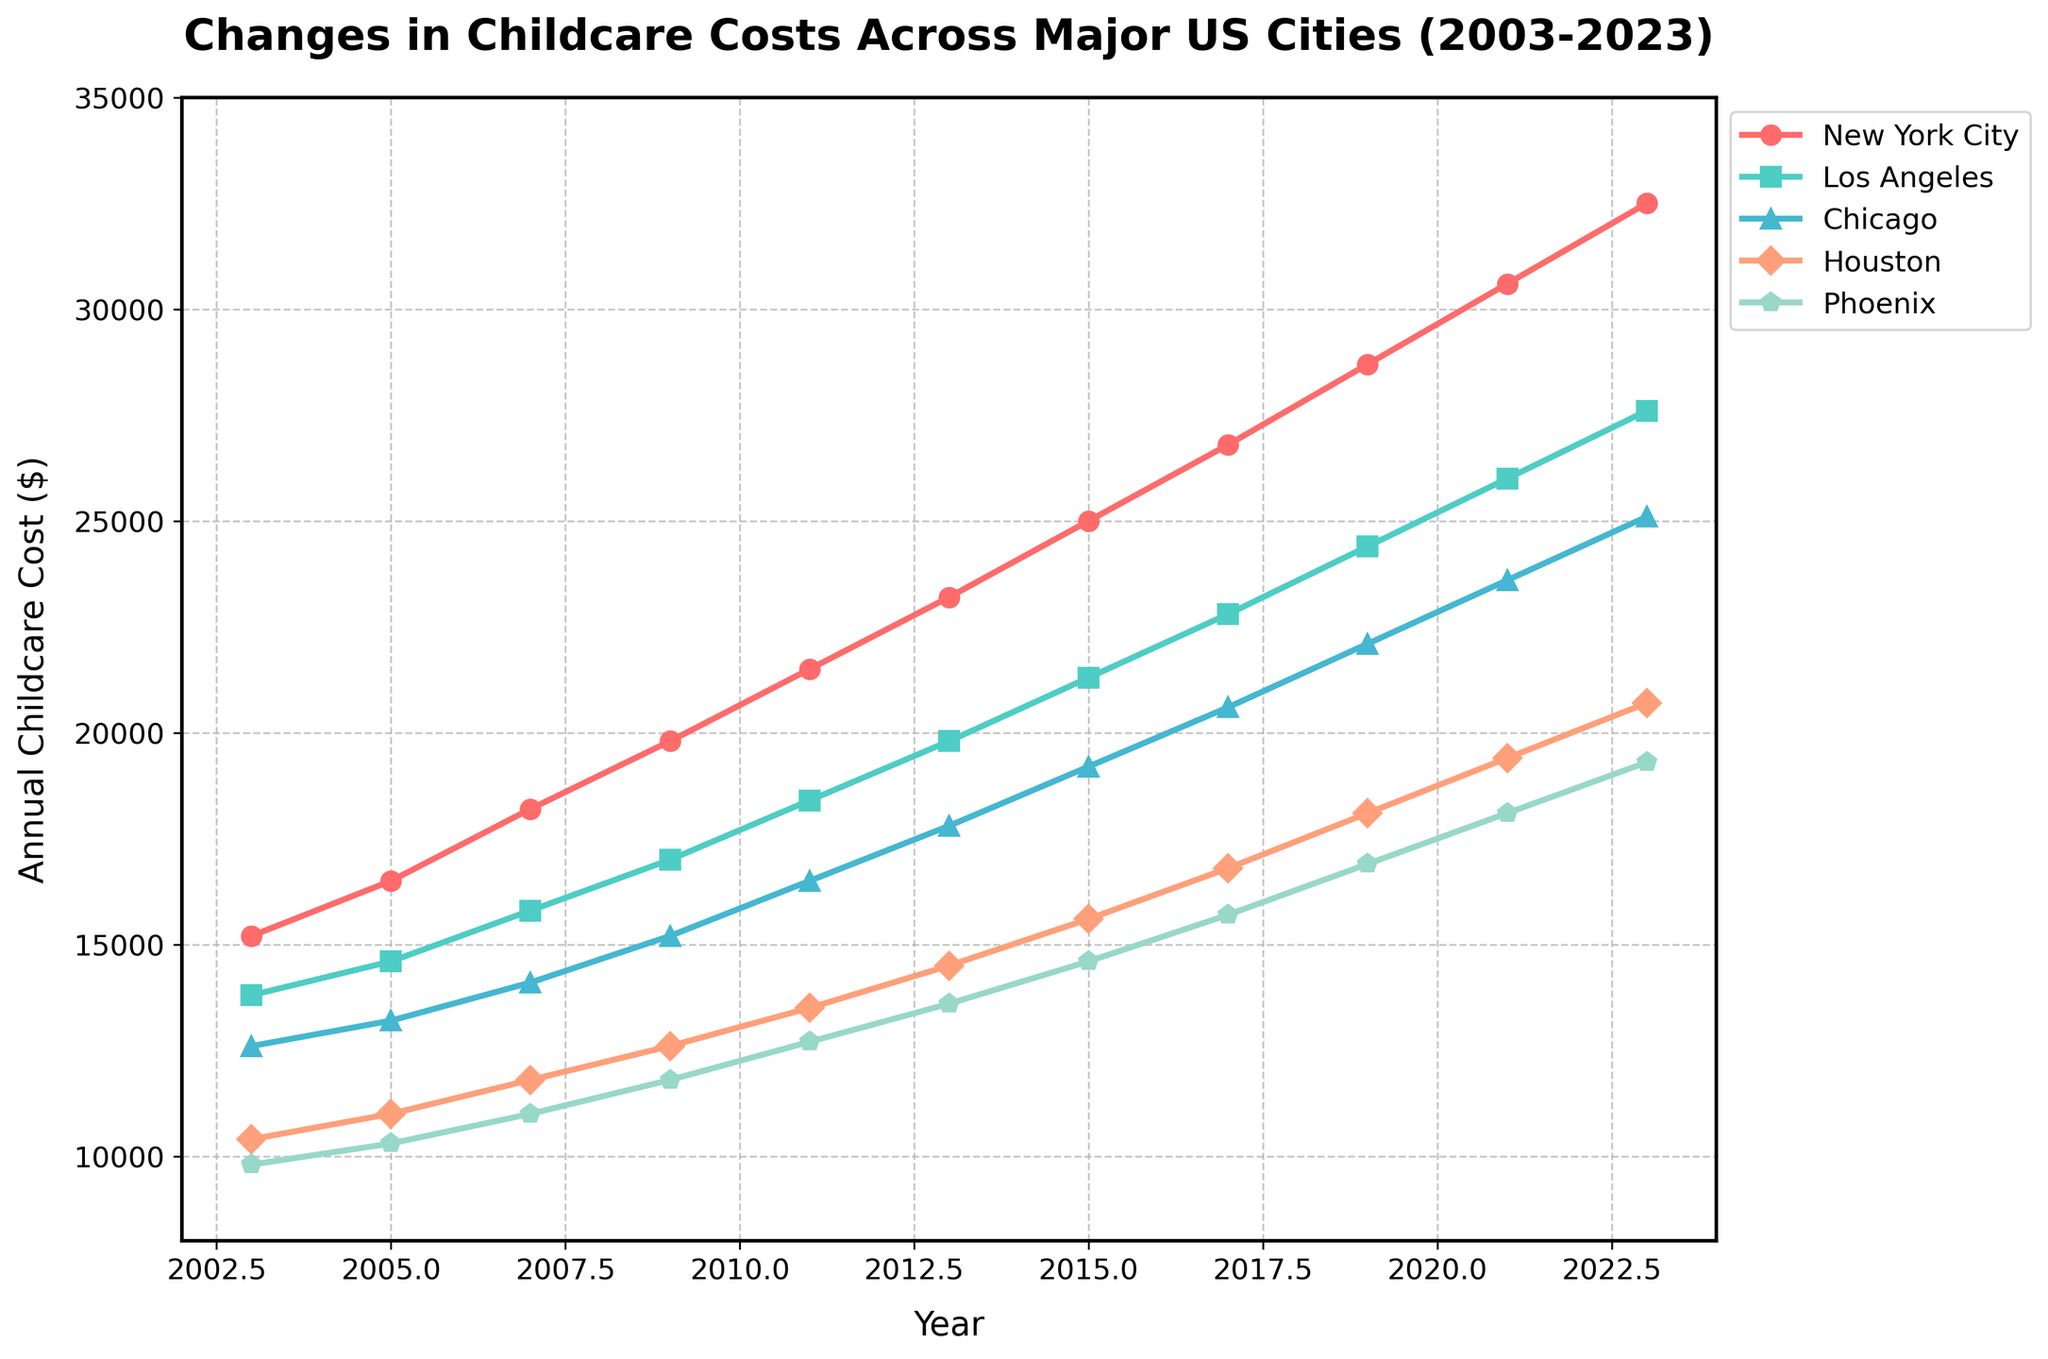What was the highest childcare cost recorded in 2023, and in which city? The highest childcare cost can be observed at the tallest point in 2023. By comparing each city's data point in 2023, we see that New York City has the highest cost.
Answer: New York City, $32,500 Which city had the most significant increase in childcare costs from 2003 to 2023? To find the most significant increase, we look at the difference between the 2023 and 2003 costs for each city: New York City ($32,500 - $15,200 = $17,300), Los Angeles ($27,600 - $13,800 = $13,800), Chicago ($25,100 - $12,600 = $12,500), Houston ($20,700 - $10,400 = $10,300), Phoenix ($19,300 - $9,800 = $9,500). The largest increase is in New York City.
Answer: New York City Compare the childcare costs of Los Angeles and Houston in 2011. Which city had higher costs, and by how much? In 2011, Los Angeles had a cost of $18,400 and Houston had $13,500. The difference is $18,400 - $13,500 = $4,900, with Los Angeles being more expensive.
Answer: Los Angeles, $4,900 Estimate the average annual increase in childcare costs for Chicago between 2003 and 2023. First, find the total increase from 2003 to 2023: $25,100 - $12,600 = $12,500. Next, divide by the number of years (2023-2003 = 20 years). $12,500 / 20 = $625 per year.
Answer: $625 per year Which city experienced the lowest average annual increase in childcare costs from 2003 to 2023? Calculate the average annual increase for each city: 
New York City: ($32,500 - $15,200) / 20 = $865 
Los Angeles: ($27,600 - $13,800) / 20 = $690 
Chicago: ($25,100 - $12,600) / 20 = $625 
Houston: ($20,700 - $10,400) / 20 = $515 
Phoenix: ($19,300 - $9,800) / 20 = $475 
Phoenix has the lowest average annual increase.
Answer: Phoenix, $475 per year In which year did Phoenix first surpass an annual childcare cost of $15,000? By inspecting the plot for Phoenix, we see it first surpasses $15,000 between 2015 and 2017. Checking the plot, 2015 is still below $15,000, so it's 2017.
Answer: 2017 How did the childcare costs trend in Houston from 2007 to 2013? Examine the plot for Houston between 2007 and 2013. In 2007, the cost was $11,800, and by 2013 it reached $14,500. The trend shows a gradual increase.
Answer: Increasing Trend Which city had the closest childcare cost to the overall average cost of all cities in 2023? First, find the average 2023 cost for all cities: 
($32,500 + $27,600 + $25,100 + $20,700 + $19,300) / 5 = $25,840 
Phoenix is the closest with $19,300. Calculate absolute differences:
New York City: $32,500 - $25,840 = $6,660
Los Angeles: $27,600 - $25,840 = $1,760
Chicago: $25,100 - $25,840 = $740
Houston: $20,700 - $25,840 = $5,140
Phoenix: $25,840 - $19,300 = $6,540
Chicago has the closest value.
Answer: Chicago Determine the median childcare cost for Phoenix from 2003 to 2023. The median is the middle value when data is ordered. Phoenix’s costs in ascending order are $9,800, $10,300, $11,000, $11,800, $12,700, $13,600, $14,600, $15,700, $16,900, $18,100, $19,300. The median value is the 6th value: $13,600.
Answer: $13,600 Which two cities' childcare costs were closest in 2019, and what was the difference? In 2019, 
New York City: $28,700 
Los Angeles: $24,400 
Chicago: $22,100 
Houston: $18,100 
Phoenix: $16,900
The closest are Houston and Phoenix. Difference: $18,100 - $16,900 = $1,200.
Answer: Houston and Phoenix, $1,200 